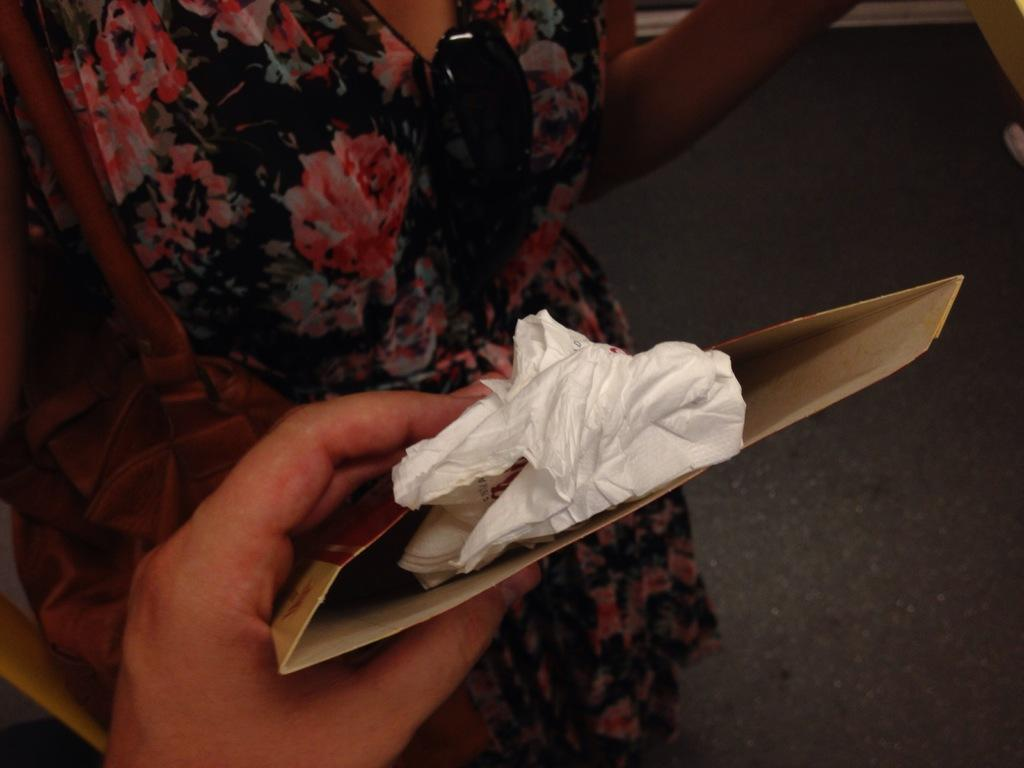Who is present in the image? There is there a woman in the image? What is the woman wearing? The woman is wearing a black dress. What is the woman holding in the image? The woman is holding a bag. Can you describe the hand in the front of the image? There is a hand holding a cover in the front of the image. What type of coast can be seen in the background of the image? There is no coast visible in the image; it only features a woman, a black dress, a bag, and a hand holding a cover. How many eyes are visible on the woman's face in the image? The image does not show the woman's face, so it is impossible to determine the number of eyes visible. 